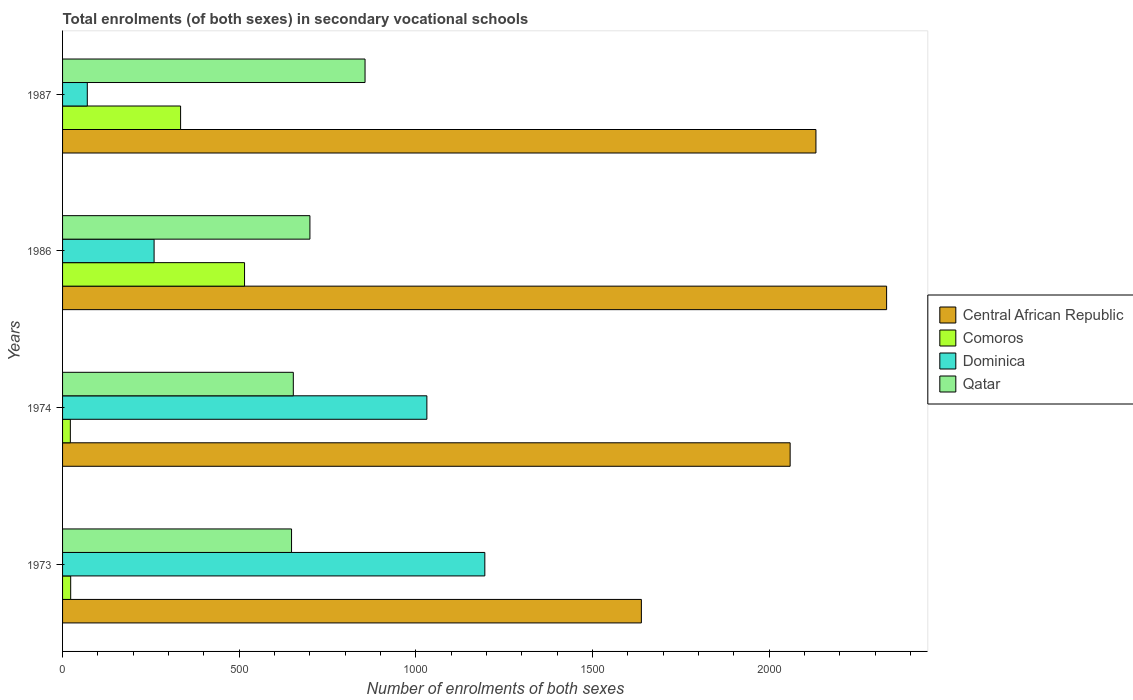How many different coloured bars are there?
Provide a succinct answer. 4. Are the number of bars on each tick of the Y-axis equal?
Offer a very short reply. Yes. What is the label of the 4th group of bars from the top?
Keep it short and to the point. 1973. What is the number of enrolments in secondary schools in Qatar in 1974?
Provide a short and direct response. 653. Across all years, what is the maximum number of enrolments in secondary schools in Qatar?
Your response must be concise. 856. Across all years, what is the minimum number of enrolments in secondary schools in Qatar?
Keep it short and to the point. 648. What is the total number of enrolments in secondary schools in Comoros in the graph?
Offer a very short reply. 894. What is the difference between the number of enrolments in secondary schools in Central African Republic in 1973 and that in 1974?
Offer a very short reply. -421. What is the difference between the number of enrolments in secondary schools in Qatar in 1987 and the number of enrolments in secondary schools in Dominica in 1986?
Keep it short and to the point. 597. What is the average number of enrolments in secondary schools in Qatar per year?
Ensure brevity in your answer.  714.25. In the year 1973, what is the difference between the number of enrolments in secondary schools in Central African Republic and number of enrolments in secondary schools in Comoros?
Offer a very short reply. 1615. In how many years, is the number of enrolments in secondary schools in Qatar greater than 1900 ?
Your answer should be very brief. 0. Is the difference between the number of enrolments in secondary schools in Central African Republic in 1974 and 1987 greater than the difference between the number of enrolments in secondary schools in Comoros in 1974 and 1987?
Offer a very short reply. Yes. What is the difference between the highest and the second highest number of enrolments in secondary schools in Comoros?
Keep it short and to the point. 181. What is the difference between the highest and the lowest number of enrolments in secondary schools in Dominica?
Keep it short and to the point. 1125. In how many years, is the number of enrolments in secondary schools in Comoros greater than the average number of enrolments in secondary schools in Comoros taken over all years?
Keep it short and to the point. 2. What does the 2nd bar from the top in 1973 represents?
Your answer should be compact. Dominica. What does the 2nd bar from the bottom in 1986 represents?
Keep it short and to the point. Comoros. Are all the bars in the graph horizontal?
Keep it short and to the point. Yes. What is the difference between two consecutive major ticks on the X-axis?
Make the answer very short. 500. Does the graph contain any zero values?
Your answer should be compact. No. Does the graph contain grids?
Your answer should be very brief. No. Where does the legend appear in the graph?
Provide a succinct answer. Center right. How are the legend labels stacked?
Keep it short and to the point. Vertical. What is the title of the graph?
Your answer should be compact. Total enrolments (of both sexes) in secondary vocational schools. What is the label or title of the X-axis?
Your answer should be very brief. Number of enrolments of both sexes. What is the label or title of the Y-axis?
Provide a succinct answer. Years. What is the Number of enrolments of both sexes of Central African Republic in 1973?
Keep it short and to the point. 1638. What is the Number of enrolments of both sexes of Dominica in 1973?
Keep it short and to the point. 1195. What is the Number of enrolments of both sexes in Qatar in 1973?
Offer a very short reply. 648. What is the Number of enrolments of both sexes in Central African Republic in 1974?
Offer a terse response. 2059. What is the Number of enrolments of both sexes of Comoros in 1974?
Your response must be concise. 22. What is the Number of enrolments of both sexes of Dominica in 1974?
Offer a terse response. 1031. What is the Number of enrolments of both sexes in Qatar in 1974?
Offer a very short reply. 653. What is the Number of enrolments of both sexes of Central African Republic in 1986?
Ensure brevity in your answer.  2332. What is the Number of enrolments of both sexes in Comoros in 1986?
Your answer should be compact. 515. What is the Number of enrolments of both sexes of Dominica in 1986?
Your answer should be compact. 259. What is the Number of enrolments of both sexes in Qatar in 1986?
Provide a succinct answer. 700. What is the Number of enrolments of both sexes of Central African Republic in 1987?
Provide a succinct answer. 2132. What is the Number of enrolments of both sexes in Comoros in 1987?
Offer a very short reply. 334. What is the Number of enrolments of both sexes in Dominica in 1987?
Provide a short and direct response. 70. What is the Number of enrolments of both sexes of Qatar in 1987?
Give a very brief answer. 856. Across all years, what is the maximum Number of enrolments of both sexes in Central African Republic?
Provide a short and direct response. 2332. Across all years, what is the maximum Number of enrolments of both sexes in Comoros?
Your answer should be very brief. 515. Across all years, what is the maximum Number of enrolments of both sexes of Dominica?
Ensure brevity in your answer.  1195. Across all years, what is the maximum Number of enrolments of both sexes in Qatar?
Provide a succinct answer. 856. Across all years, what is the minimum Number of enrolments of both sexes in Central African Republic?
Offer a very short reply. 1638. Across all years, what is the minimum Number of enrolments of both sexes in Comoros?
Your answer should be compact. 22. Across all years, what is the minimum Number of enrolments of both sexes in Dominica?
Give a very brief answer. 70. Across all years, what is the minimum Number of enrolments of both sexes of Qatar?
Make the answer very short. 648. What is the total Number of enrolments of both sexes in Central African Republic in the graph?
Your answer should be very brief. 8161. What is the total Number of enrolments of both sexes of Comoros in the graph?
Make the answer very short. 894. What is the total Number of enrolments of both sexes in Dominica in the graph?
Keep it short and to the point. 2555. What is the total Number of enrolments of both sexes in Qatar in the graph?
Your response must be concise. 2857. What is the difference between the Number of enrolments of both sexes of Central African Republic in 1973 and that in 1974?
Provide a succinct answer. -421. What is the difference between the Number of enrolments of both sexes of Comoros in 1973 and that in 1974?
Make the answer very short. 1. What is the difference between the Number of enrolments of both sexes of Dominica in 1973 and that in 1974?
Make the answer very short. 164. What is the difference between the Number of enrolments of both sexes of Central African Republic in 1973 and that in 1986?
Your answer should be compact. -694. What is the difference between the Number of enrolments of both sexes of Comoros in 1973 and that in 1986?
Keep it short and to the point. -492. What is the difference between the Number of enrolments of both sexes in Dominica in 1973 and that in 1986?
Ensure brevity in your answer.  936. What is the difference between the Number of enrolments of both sexes of Qatar in 1973 and that in 1986?
Give a very brief answer. -52. What is the difference between the Number of enrolments of both sexes of Central African Republic in 1973 and that in 1987?
Ensure brevity in your answer.  -494. What is the difference between the Number of enrolments of both sexes of Comoros in 1973 and that in 1987?
Give a very brief answer. -311. What is the difference between the Number of enrolments of both sexes of Dominica in 1973 and that in 1987?
Your response must be concise. 1125. What is the difference between the Number of enrolments of both sexes of Qatar in 1973 and that in 1987?
Provide a short and direct response. -208. What is the difference between the Number of enrolments of both sexes in Central African Republic in 1974 and that in 1986?
Your answer should be compact. -273. What is the difference between the Number of enrolments of both sexes in Comoros in 1974 and that in 1986?
Offer a terse response. -493. What is the difference between the Number of enrolments of both sexes of Dominica in 1974 and that in 1986?
Your answer should be compact. 772. What is the difference between the Number of enrolments of both sexes in Qatar in 1974 and that in 1986?
Offer a terse response. -47. What is the difference between the Number of enrolments of both sexes of Central African Republic in 1974 and that in 1987?
Make the answer very short. -73. What is the difference between the Number of enrolments of both sexes in Comoros in 1974 and that in 1987?
Provide a short and direct response. -312. What is the difference between the Number of enrolments of both sexes of Dominica in 1974 and that in 1987?
Make the answer very short. 961. What is the difference between the Number of enrolments of both sexes of Qatar in 1974 and that in 1987?
Offer a terse response. -203. What is the difference between the Number of enrolments of both sexes of Comoros in 1986 and that in 1987?
Your response must be concise. 181. What is the difference between the Number of enrolments of both sexes of Dominica in 1986 and that in 1987?
Offer a very short reply. 189. What is the difference between the Number of enrolments of both sexes of Qatar in 1986 and that in 1987?
Keep it short and to the point. -156. What is the difference between the Number of enrolments of both sexes of Central African Republic in 1973 and the Number of enrolments of both sexes of Comoros in 1974?
Provide a succinct answer. 1616. What is the difference between the Number of enrolments of both sexes in Central African Republic in 1973 and the Number of enrolments of both sexes in Dominica in 1974?
Your answer should be very brief. 607. What is the difference between the Number of enrolments of both sexes of Central African Republic in 1973 and the Number of enrolments of both sexes of Qatar in 1974?
Ensure brevity in your answer.  985. What is the difference between the Number of enrolments of both sexes in Comoros in 1973 and the Number of enrolments of both sexes in Dominica in 1974?
Your answer should be compact. -1008. What is the difference between the Number of enrolments of both sexes in Comoros in 1973 and the Number of enrolments of both sexes in Qatar in 1974?
Ensure brevity in your answer.  -630. What is the difference between the Number of enrolments of both sexes in Dominica in 1973 and the Number of enrolments of both sexes in Qatar in 1974?
Your response must be concise. 542. What is the difference between the Number of enrolments of both sexes of Central African Republic in 1973 and the Number of enrolments of both sexes of Comoros in 1986?
Your answer should be compact. 1123. What is the difference between the Number of enrolments of both sexes in Central African Republic in 1973 and the Number of enrolments of both sexes in Dominica in 1986?
Provide a short and direct response. 1379. What is the difference between the Number of enrolments of both sexes of Central African Republic in 1973 and the Number of enrolments of both sexes of Qatar in 1986?
Offer a terse response. 938. What is the difference between the Number of enrolments of both sexes of Comoros in 1973 and the Number of enrolments of both sexes of Dominica in 1986?
Offer a very short reply. -236. What is the difference between the Number of enrolments of both sexes of Comoros in 1973 and the Number of enrolments of both sexes of Qatar in 1986?
Give a very brief answer. -677. What is the difference between the Number of enrolments of both sexes of Dominica in 1973 and the Number of enrolments of both sexes of Qatar in 1986?
Ensure brevity in your answer.  495. What is the difference between the Number of enrolments of both sexes in Central African Republic in 1973 and the Number of enrolments of both sexes in Comoros in 1987?
Give a very brief answer. 1304. What is the difference between the Number of enrolments of both sexes in Central African Republic in 1973 and the Number of enrolments of both sexes in Dominica in 1987?
Your answer should be compact. 1568. What is the difference between the Number of enrolments of both sexes in Central African Republic in 1973 and the Number of enrolments of both sexes in Qatar in 1987?
Your response must be concise. 782. What is the difference between the Number of enrolments of both sexes of Comoros in 1973 and the Number of enrolments of both sexes of Dominica in 1987?
Offer a terse response. -47. What is the difference between the Number of enrolments of both sexes in Comoros in 1973 and the Number of enrolments of both sexes in Qatar in 1987?
Your answer should be compact. -833. What is the difference between the Number of enrolments of both sexes of Dominica in 1973 and the Number of enrolments of both sexes of Qatar in 1987?
Offer a terse response. 339. What is the difference between the Number of enrolments of both sexes in Central African Republic in 1974 and the Number of enrolments of both sexes in Comoros in 1986?
Make the answer very short. 1544. What is the difference between the Number of enrolments of both sexes in Central African Republic in 1974 and the Number of enrolments of both sexes in Dominica in 1986?
Make the answer very short. 1800. What is the difference between the Number of enrolments of both sexes in Central African Republic in 1974 and the Number of enrolments of both sexes in Qatar in 1986?
Give a very brief answer. 1359. What is the difference between the Number of enrolments of both sexes of Comoros in 1974 and the Number of enrolments of both sexes of Dominica in 1986?
Give a very brief answer. -237. What is the difference between the Number of enrolments of both sexes of Comoros in 1974 and the Number of enrolments of both sexes of Qatar in 1986?
Keep it short and to the point. -678. What is the difference between the Number of enrolments of both sexes of Dominica in 1974 and the Number of enrolments of both sexes of Qatar in 1986?
Your answer should be very brief. 331. What is the difference between the Number of enrolments of both sexes of Central African Republic in 1974 and the Number of enrolments of both sexes of Comoros in 1987?
Your answer should be compact. 1725. What is the difference between the Number of enrolments of both sexes in Central African Republic in 1974 and the Number of enrolments of both sexes in Dominica in 1987?
Your response must be concise. 1989. What is the difference between the Number of enrolments of both sexes in Central African Republic in 1974 and the Number of enrolments of both sexes in Qatar in 1987?
Ensure brevity in your answer.  1203. What is the difference between the Number of enrolments of both sexes of Comoros in 1974 and the Number of enrolments of both sexes of Dominica in 1987?
Your answer should be very brief. -48. What is the difference between the Number of enrolments of both sexes in Comoros in 1974 and the Number of enrolments of both sexes in Qatar in 1987?
Give a very brief answer. -834. What is the difference between the Number of enrolments of both sexes in Dominica in 1974 and the Number of enrolments of both sexes in Qatar in 1987?
Offer a terse response. 175. What is the difference between the Number of enrolments of both sexes in Central African Republic in 1986 and the Number of enrolments of both sexes in Comoros in 1987?
Give a very brief answer. 1998. What is the difference between the Number of enrolments of both sexes in Central African Republic in 1986 and the Number of enrolments of both sexes in Dominica in 1987?
Your response must be concise. 2262. What is the difference between the Number of enrolments of both sexes in Central African Republic in 1986 and the Number of enrolments of both sexes in Qatar in 1987?
Give a very brief answer. 1476. What is the difference between the Number of enrolments of both sexes of Comoros in 1986 and the Number of enrolments of both sexes of Dominica in 1987?
Offer a very short reply. 445. What is the difference between the Number of enrolments of both sexes in Comoros in 1986 and the Number of enrolments of both sexes in Qatar in 1987?
Your answer should be very brief. -341. What is the difference between the Number of enrolments of both sexes of Dominica in 1986 and the Number of enrolments of both sexes of Qatar in 1987?
Give a very brief answer. -597. What is the average Number of enrolments of both sexes in Central African Republic per year?
Offer a terse response. 2040.25. What is the average Number of enrolments of both sexes in Comoros per year?
Provide a succinct answer. 223.5. What is the average Number of enrolments of both sexes of Dominica per year?
Give a very brief answer. 638.75. What is the average Number of enrolments of both sexes in Qatar per year?
Ensure brevity in your answer.  714.25. In the year 1973, what is the difference between the Number of enrolments of both sexes of Central African Republic and Number of enrolments of both sexes of Comoros?
Your answer should be compact. 1615. In the year 1973, what is the difference between the Number of enrolments of both sexes of Central African Republic and Number of enrolments of both sexes of Dominica?
Your answer should be very brief. 443. In the year 1973, what is the difference between the Number of enrolments of both sexes of Central African Republic and Number of enrolments of both sexes of Qatar?
Your response must be concise. 990. In the year 1973, what is the difference between the Number of enrolments of both sexes of Comoros and Number of enrolments of both sexes of Dominica?
Give a very brief answer. -1172. In the year 1973, what is the difference between the Number of enrolments of both sexes of Comoros and Number of enrolments of both sexes of Qatar?
Provide a short and direct response. -625. In the year 1973, what is the difference between the Number of enrolments of both sexes of Dominica and Number of enrolments of both sexes of Qatar?
Give a very brief answer. 547. In the year 1974, what is the difference between the Number of enrolments of both sexes in Central African Republic and Number of enrolments of both sexes in Comoros?
Your answer should be compact. 2037. In the year 1974, what is the difference between the Number of enrolments of both sexes of Central African Republic and Number of enrolments of both sexes of Dominica?
Ensure brevity in your answer.  1028. In the year 1974, what is the difference between the Number of enrolments of both sexes in Central African Republic and Number of enrolments of both sexes in Qatar?
Offer a very short reply. 1406. In the year 1974, what is the difference between the Number of enrolments of both sexes in Comoros and Number of enrolments of both sexes in Dominica?
Make the answer very short. -1009. In the year 1974, what is the difference between the Number of enrolments of both sexes of Comoros and Number of enrolments of both sexes of Qatar?
Offer a very short reply. -631. In the year 1974, what is the difference between the Number of enrolments of both sexes in Dominica and Number of enrolments of both sexes in Qatar?
Your answer should be compact. 378. In the year 1986, what is the difference between the Number of enrolments of both sexes of Central African Republic and Number of enrolments of both sexes of Comoros?
Offer a very short reply. 1817. In the year 1986, what is the difference between the Number of enrolments of both sexes of Central African Republic and Number of enrolments of both sexes of Dominica?
Keep it short and to the point. 2073. In the year 1986, what is the difference between the Number of enrolments of both sexes in Central African Republic and Number of enrolments of both sexes in Qatar?
Provide a succinct answer. 1632. In the year 1986, what is the difference between the Number of enrolments of both sexes of Comoros and Number of enrolments of both sexes of Dominica?
Offer a very short reply. 256. In the year 1986, what is the difference between the Number of enrolments of both sexes of Comoros and Number of enrolments of both sexes of Qatar?
Make the answer very short. -185. In the year 1986, what is the difference between the Number of enrolments of both sexes in Dominica and Number of enrolments of both sexes in Qatar?
Give a very brief answer. -441. In the year 1987, what is the difference between the Number of enrolments of both sexes in Central African Republic and Number of enrolments of both sexes in Comoros?
Give a very brief answer. 1798. In the year 1987, what is the difference between the Number of enrolments of both sexes in Central African Republic and Number of enrolments of both sexes in Dominica?
Make the answer very short. 2062. In the year 1987, what is the difference between the Number of enrolments of both sexes of Central African Republic and Number of enrolments of both sexes of Qatar?
Give a very brief answer. 1276. In the year 1987, what is the difference between the Number of enrolments of both sexes in Comoros and Number of enrolments of both sexes in Dominica?
Offer a terse response. 264. In the year 1987, what is the difference between the Number of enrolments of both sexes of Comoros and Number of enrolments of both sexes of Qatar?
Provide a short and direct response. -522. In the year 1987, what is the difference between the Number of enrolments of both sexes in Dominica and Number of enrolments of both sexes in Qatar?
Offer a very short reply. -786. What is the ratio of the Number of enrolments of both sexes in Central African Republic in 1973 to that in 1974?
Provide a succinct answer. 0.8. What is the ratio of the Number of enrolments of both sexes of Comoros in 1973 to that in 1974?
Your answer should be very brief. 1.05. What is the ratio of the Number of enrolments of both sexes in Dominica in 1973 to that in 1974?
Make the answer very short. 1.16. What is the ratio of the Number of enrolments of both sexes in Central African Republic in 1973 to that in 1986?
Give a very brief answer. 0.7. What is the ratio of the Number of enrolments of both sexes in Comoros in 1973 to that in 1986?
Give a very brief answer. 0.04. What is the ratio of the Number of enrolments of both sexes of Dominica in 1973 to that in 1986?
Give a very brief answer. 4.61. What is the ratio of the Number of enrolments of both sexes of Qatar in 1973 to that in 1986?
Give a very brief answer. 0.93. What is the ratio of the Number of enrolments of both sexes of Central African Republic in 1973 to that in 1987?
Your response must be concise. 0.77. What is the ratio of the Number of enrolments of both sexes in Comoros in 1973 to that in 1987?
Offer a very short reply. 0.07. What is the ratio of the Number of enrolments of both sexes of Dominica in 1973 to that in 1987?
Give a very brief answer. 17.07. What is the ratio of the Number of enrolments of both sexes of Qatar in 1973 to that in 1987?
Give a very brief answer. 0.76. What is the ratio of the Number of enrolments of both sexes in Central African Republic in 1974 to that in 1986?
Ensure brevity in your answer.  0.88. What is the ratio of the Number of enrolments of both sexes of Comoros in 1974 to that in 1986?
Provide a short and direct response. 0.04. What is the ratio of the Number of enrolments of both sexes in Dominica in 1974 to that in 1986?
Ensure brevity in your answer.  3.98. What is the ratio of the Number of enrolments of both sexes in Qatar in 1974 to that in 1986?
Provide a short and direct response. 0.93. What is the ratio of the Number of enrolments of both sexes in Central African Republic in 1974 to that in 1987?
Offer a very short reply. 0.97. What is the ratio of the Number of enrolments of both sexes of Comoros in 1974 to that in 1987?
Provide a succinct answer. 0.07. What is the ratio of the Number of enrolments of both sexes in Dominica in 1974 to that in 1987?
Keep it short and to the point. 14.73. What is the ratio of the Number of enrolments of both sexes of Qatar in 1974 to that in 1987?
Offer a terse response. 0.76. What is the ratio of the Number of enrolments of both sexes in Central African Republic in 1986 to that in 1987?
Offer a very short reply. 1.09. What is the ratio of the Number of enrolments of both sexes of Comoros in 1986 to that in 1987?
Make the answer very short. 1.54. What is the ratio of the Number of enrolments of both sexes of Qatar in 1986 to that in 1987?
Your answer should be very brief. 0.82. What is the difference between the highest and the second highest Number of enrolments of both sexes in Comoros?
Make the answer very short. 181. What is the difference between the highest and the second highest Number of enrolments of both sexes of Dominica?
Ensure brevity in your answer.  164. What is the difference between the highest and the second highest Number of enrolments of both sexes in Qatar?
Ensure brevity in your answer.  156. What is the difference between the highest and the lowest Number of enrolments of both sexes in Central African Republic?
Your response must be concise. 694. What is the difference between the highest and the lowest Number of enrolments of both sexes of Comoros?
Provide a succinct answer. 493. What is the difference between the highest and the lowest Number of enrolments of both sexes of Dominica?
Provide a succinct answer. 1125. What is the difference between the highest and the lowest Number of enrolments of both sexes of Qatar?
Give a very brief answer. 208. 